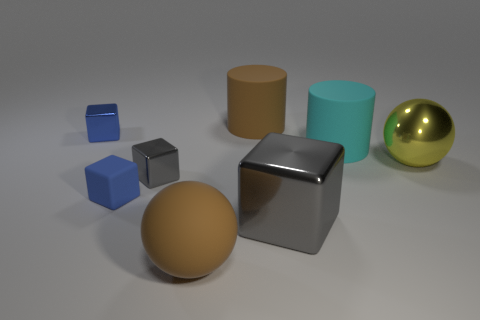Is the yellow object made of the same material as the large brown sphere?
Provide a succinct answer. No. The other matte cylinder that is the same size as the cyan cylinder is what color?
Your answer should be very brief. Brown. There is a brown thing in front of the cylinder that is to the right of the big gray block in front of the large yellow ball; what shape is it?
Offer a terse response. Sphere. There is a big brown matte thing that is behind the shiny sphere; what number of cyan things are to the right of it?
Offer a terse response. 1. Do the tiny metallic object that is on the right side of the blue rubber block and the brown thing behind the small matte object have the same shape?
Ensure brevity in your answer.  No. How many small gray shiny blocks are in front of the brown sphere?
Ensure brevity in your answer.  0. Are the cylinder right of the big gray thing and the big brown cylinder made of the same material?
Give a very brief answer. Yes. There is another rubber thing that is the same shape as the cyan thing; what color is it?
Offer a terse response. Brown. The large gray metallic object is what shape?
Your response must be concise. Cube. How many things are either large cyan matte cylinders or large balls?
Keep it short and to the point. 3. 